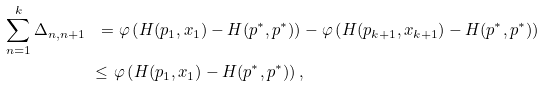Convert formula to latex. <formula><loc_0><loc_0><loc_500><loc_500>\sum _ { n = 1 } ^ { k } \Delta _ { n , n + 1 } \ = & \ \varphi \left ( H ( p _ { 1 } , x _ { 1 } ) - H ( p ^ { * } , p ^ { * } ) \right ) - \varphi \left ( H ( p _ { k + 1 } , x _ { k + 1 } ) - H ( p ^ { * } , p ^ { * } ) \right ) & \\ \leq \ & \varphi \left ( H ( p _ { 1 } , x _ { 1 } ) - H ( p ^ { * } , p ^ { * } ) \right ) , &</formula> 